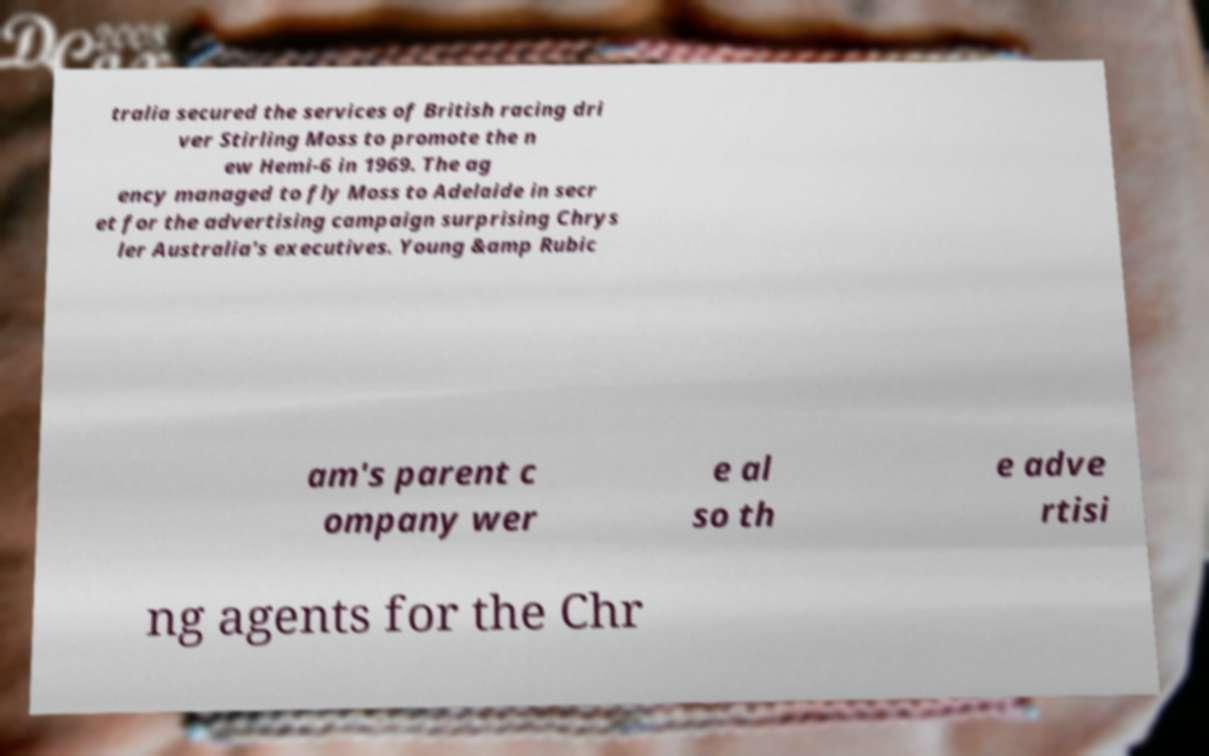I need the written content from this picture converted into text. Can you do that? tralia secured the services of British racing dri ver Stirling Moss to promote the n ew Hemi-6 in 1969. The ag ency managed to fly Moss to Adelaide in secr et for the advertising campaign surprising Chrys ler Australia's executives. Young &amp Rubic am's parent c ompany wer e al so th e adve rtisi ng agents for the Chr 